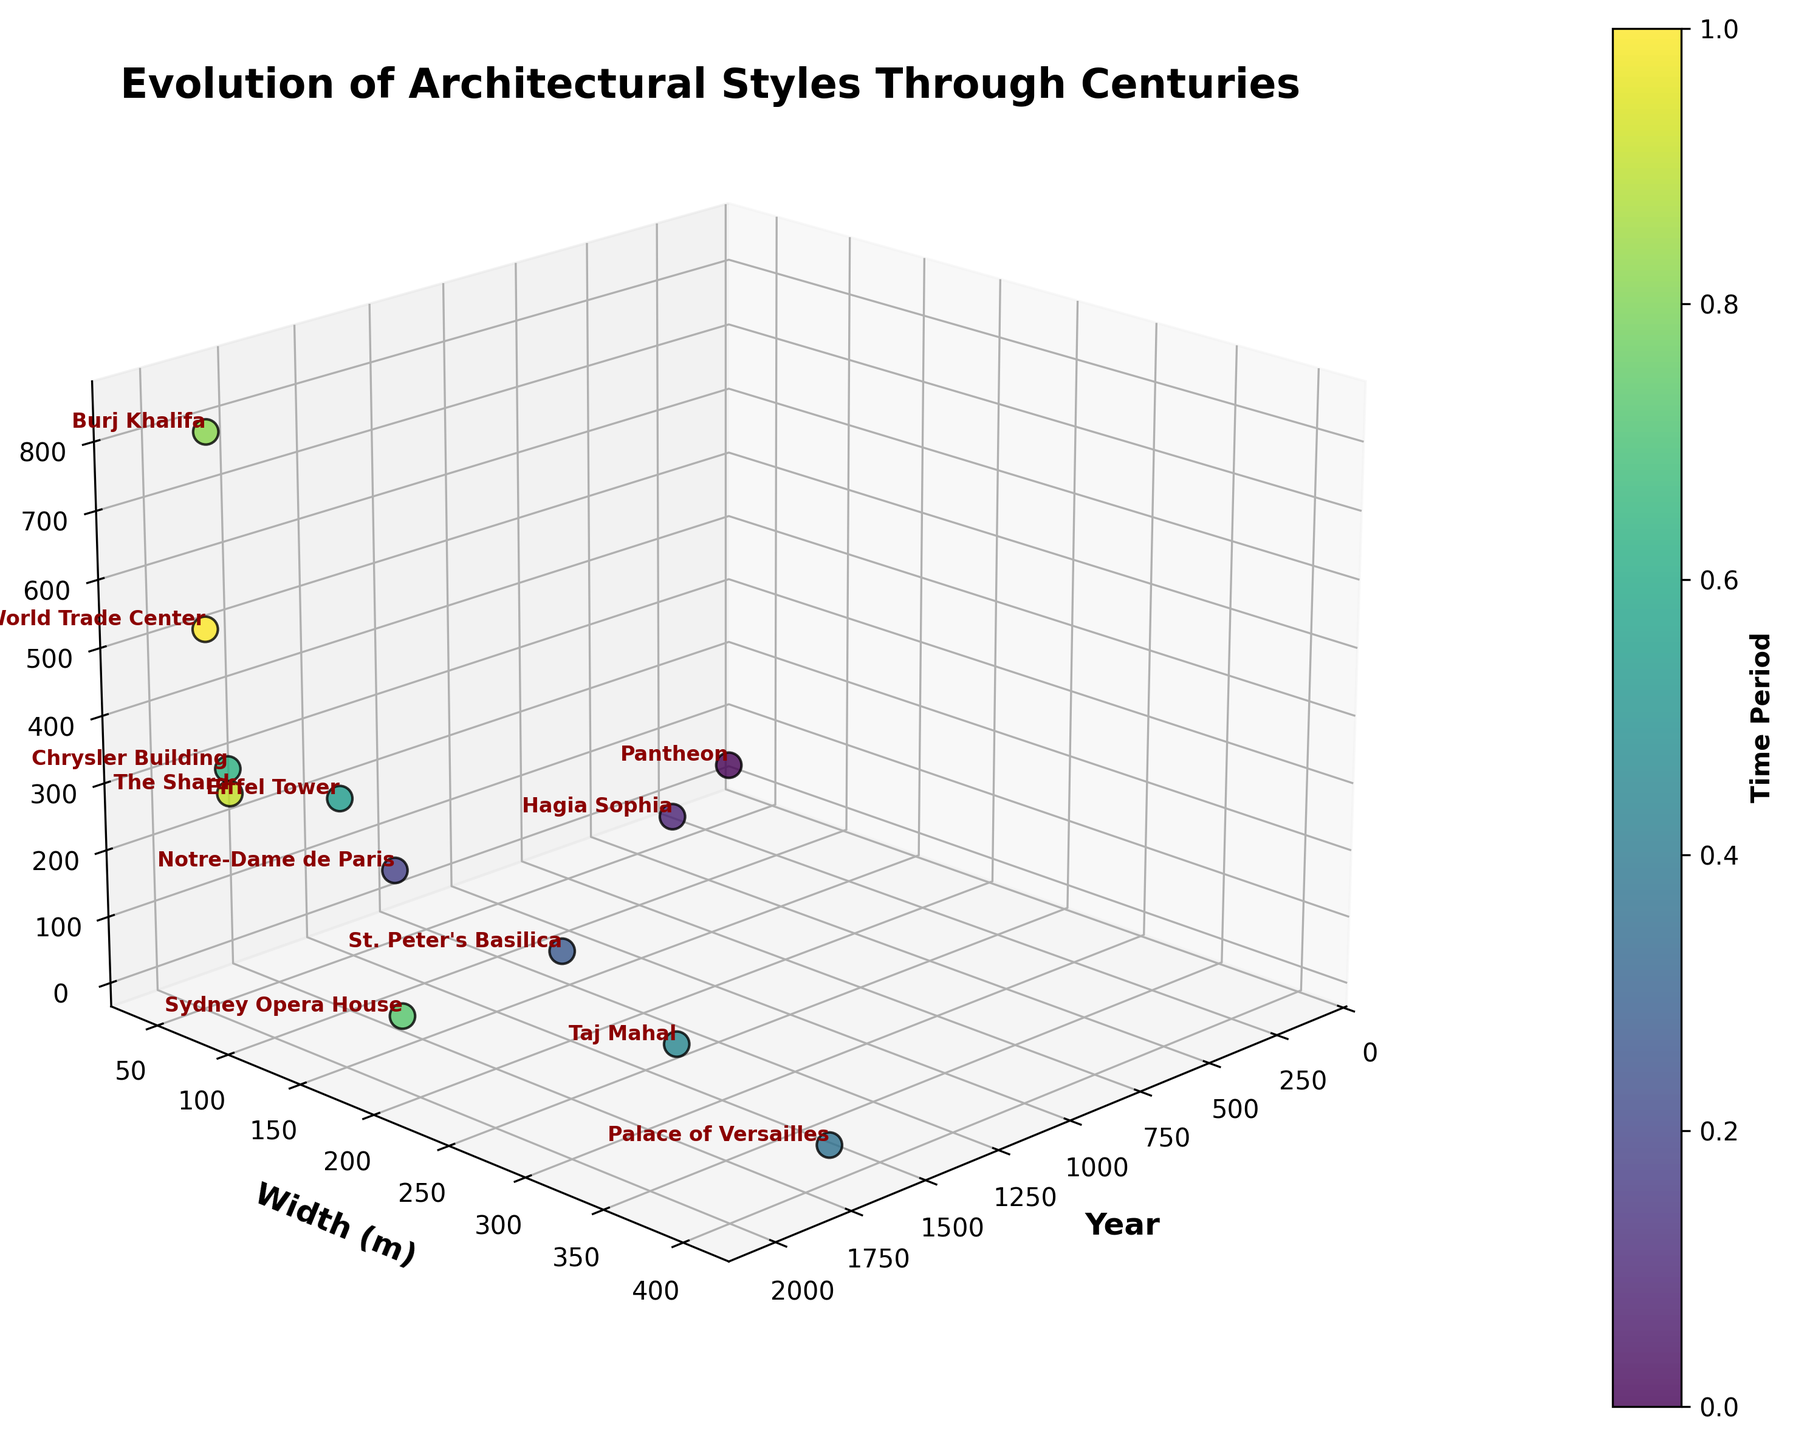What is the title of the plot? The title is prominently displayed at the top of the plot. You can directly read it to determine the title.
Answer: Evolution of Architectural Styles Through Centuries Which building is the tallest in the figure? Look at the 'Height (m)' axis and find the highest point. Check the label next to this point to identify the building.
Answer: Burj Khalifa What is the approximate height of the Sydney Opera House? Locate 'Sydney Opera House' on the plot and read the value on the 'Height (m)' axis where it is plotted.
Answer: 65 meters How does the height of the Taj Mahal compare to that of the Eiffel Tower? Identify the heights of both the Taj Mahal and the Eiffel Tower on the 'Height (m)' axis and compare the values.
Answer: The Eiffel Tower is taller In which time period did the architectural style shift from shorter to significantly taller buildings? Examine the plot along the 'Year' axis, noting changes in the 'Height (m)' values over time.
Answer: Late 19th to early 20th century Which building has the largest width and which one has the smallest width? Compare the 'Width (m)' axis values for all data points to determine the largest and smallest values. Identify the buildings associated with these values.
Answer: Palace of Versailles has the largest width, Pantheon has the smallest width How many buildings were constructed before the year 1600? Count the number of data points plotted with a 'Year' value less than 1600.
Answer: 3 What is the average height of buildings constructed in the 20th century or later? Identify the buildings constructed from 1900 onwards, sum their heights, and divide by the number of buildings to find the average height.
Answer: (319 + 65 + 828 + 310 + 541) / 5 = 412.6 meters Which building has a greater impact on the visual aspect of the plot in terms of both height and width? Assess which building has a prominent presence in both the 'Height (m)' and 'Width (m)' axes.
Answer: St. Peter's Basilica What can you infer about the changes in architectural styles based on the heights of buildings over time? Observe the trend in the 'Height (m)' values along the 'Year' axis to infer the evolution of architectural styles.
Answer: Taller buildings are a more recent trend 